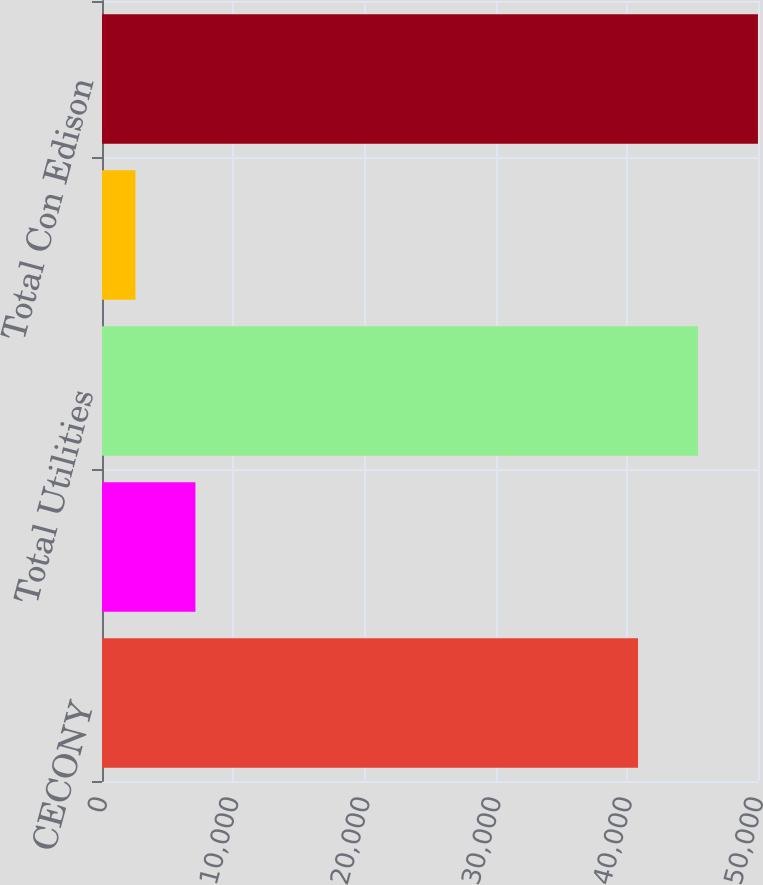<chart> <loc_0><loc_0><loc_500><loc_500><bar_chart><fcel>CECONY<fcel>O&R<fcel>Total Utilities<fcel>Clean Energy Businesses (a)<fcel>Total Con Edison<nl><fcel>40856<fcel>7121.4<fcel>45426.4<fcel>2551<fcel>49996.8<nl></chart> 